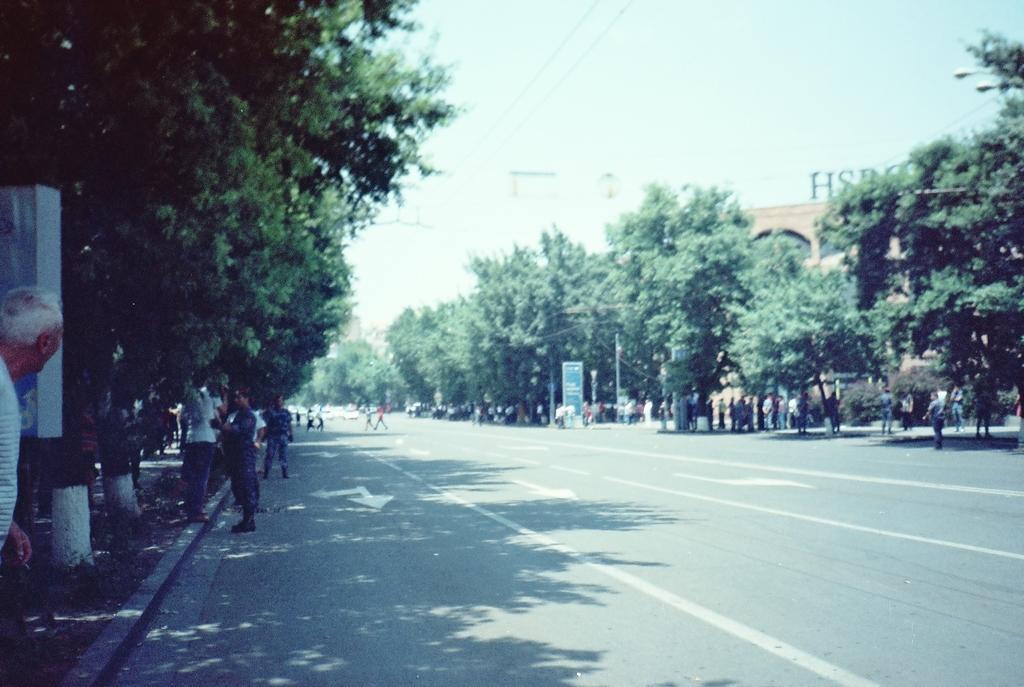Could you give a brief overview of what you see in this image? These are the trees, which are beside the road. I can see groups of people standing. This looks like a board. Here is the road. This is a building with a name board on it. 